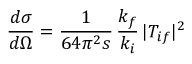<formula> <loc_0><loc_0><loc_500><loc_500>\frac { d \sigma } { d \Omega } = \frac { 1 } { 6 4 \pi ^ { 2 } s } \, \frac { k _ { f } } { k _ { i } } \, | T _ { i f } | ^ { 2 }</formula> 